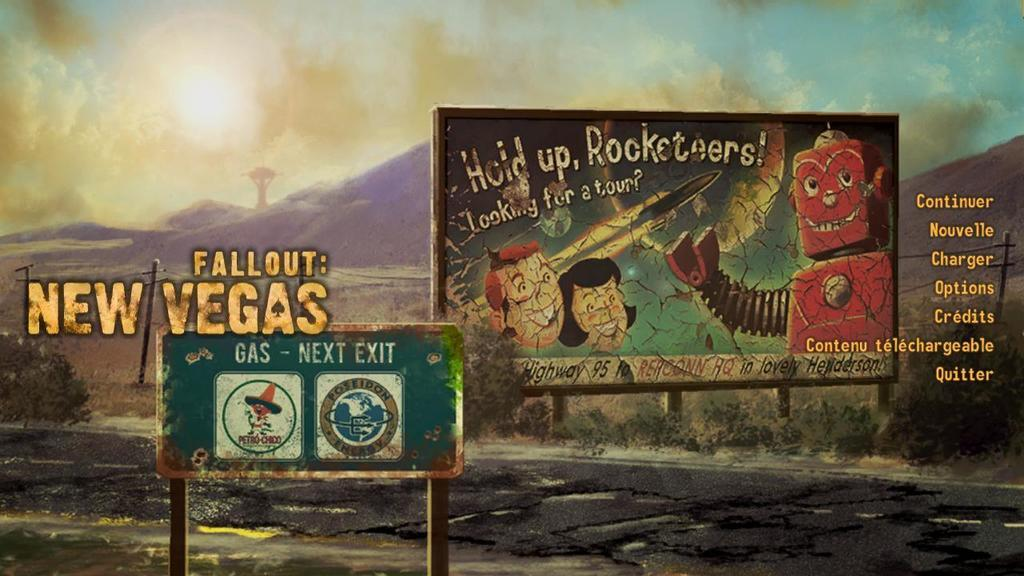What can be seen on the ad boards in the image? The ad boards have anime images on them. What else is present on the ad boards besides the images? There is text on the ad boards. What is visible in the background of the image? The sky and hills are visible in the image. How many gloves can be seen on the ad boards in the image? There are no gloves present on the ad boards in the image. What type of curve is visible on the hills in the image? There is no curve visible on the hills in the image; they appear to be straight. 